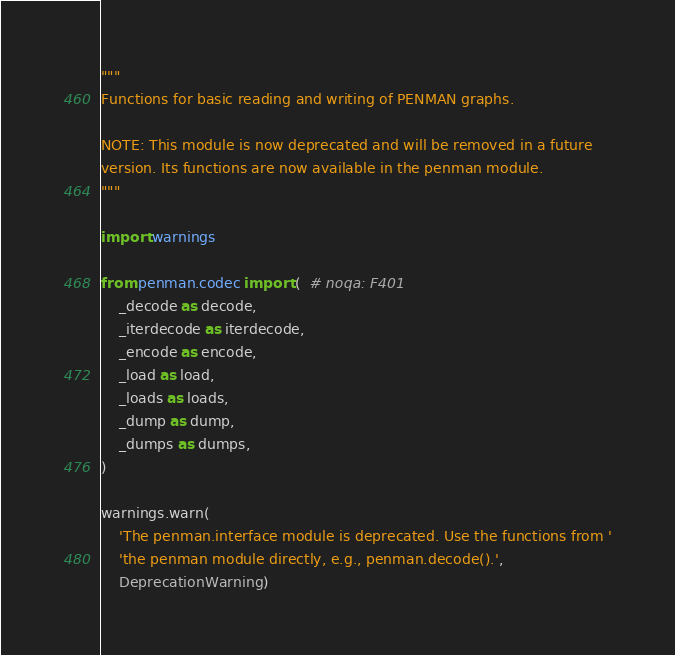Convert code to text. <code><loc_0><loc_0><loc_500><loc_500><_Python_>
"""
Functions for basic reading and writing of PENMAN graphs.

NOTE: This module is now deprecated and will be removed in a future
version. Its functions are now available in the penman module.
"""

import warnings

from penman.codec import (  # noqa: F401
    _decode as decode,
    _iterdecode as iterdecode,
    _encode as encode,
    _load as load,
    _loads as loads,
    _dump as dump,
    _dumps as dumps,
)

warnings.warn(
    'The penman.interface module is deprecated. Use the functions from '
    'the penman module directly, e.g., penman.decode().',
    DeprecationWarning)
</code> 